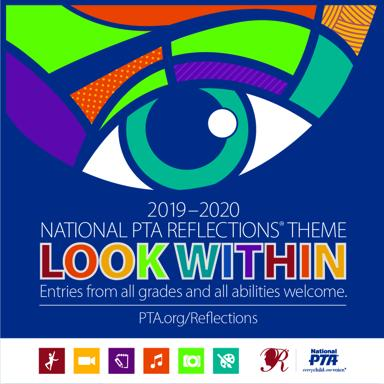What is the 2019-2020 National PTA Reflections theme? The theme for the 2019-2020 National PTA Reflections program is 'Look Within'. This initiative encourages students to explore their own thoughts, feelings, and ideas artistically as they participate in the categories of dance choreography, film production, literature, music composition, photography, and visual arts. 